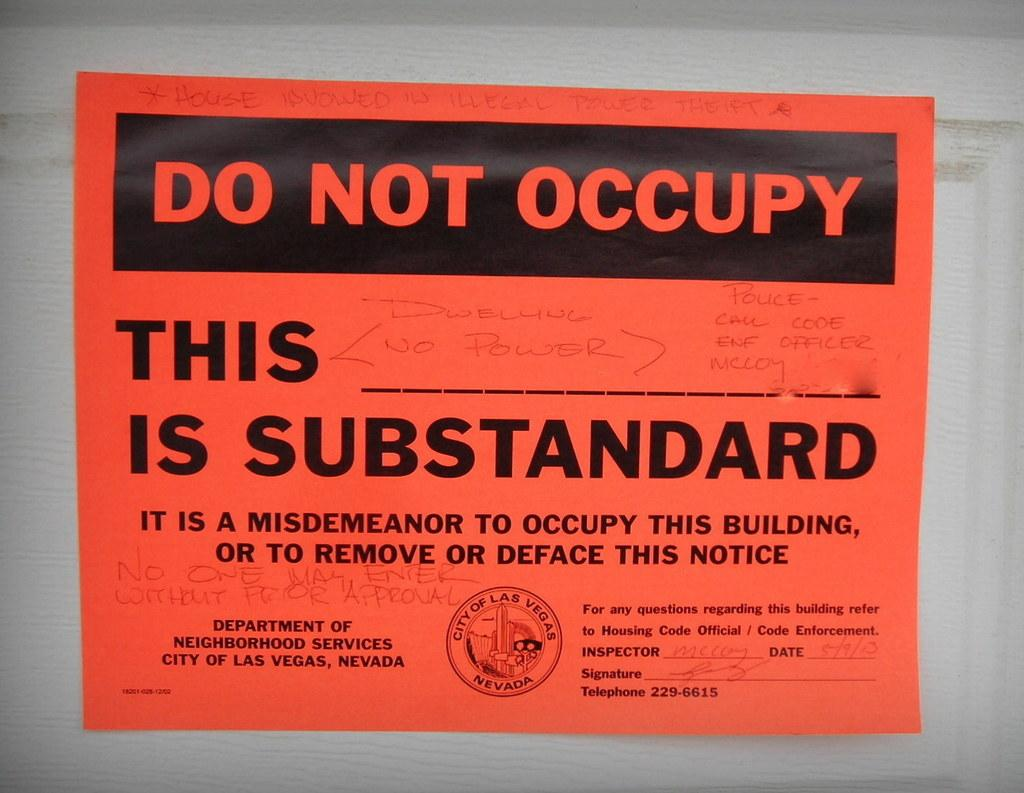<image>
Render a clear and concise summary of the photo. A do not occupay warning from the city of Las Vegas. 